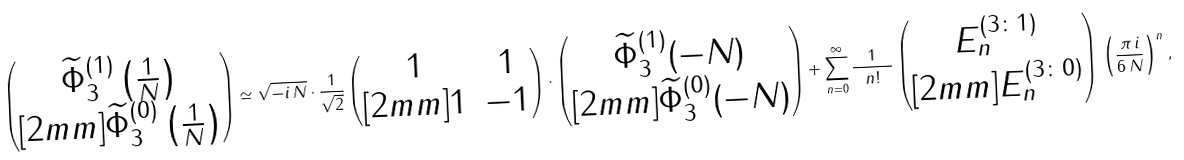<formula> <loc_0><loc_0><loc_500><loc_500>\begin{pmatrix} \widetilde { \Phi } _ { 3 } ^ { ( 1 ) } \left ( \frac { 1 } { N } \right ) \\ [ 2 m m ] \widetilde { \Phi } _ { 3 } ^ { ( 0 ) } \left ( \frac { 1 } { N } \right ) \end{pmatrix} \simeq \sqrt { - i \, N } \cdot \frac { 1 } { \sqrt { 2 } } \begin{pmatrix} 1 & 1 \\ [ 2 m m ] 1 & - 1 \end{pmatrix} \cdot \begin{pmatrix} \widetilde { \Phi } _ { 3 } ^ { ( 1 ) } ( - N ) \\ [ 2 m m ] \widetilde { \Phi } _ { 3 } ^ { ( 0 ) } ( - N ) \end{pmatrix} + \sum _ { n = 0 } ^ { \infty } \frac { 1 } { \ n ! \ } \begin{pmatrix} E _ { n } ^ { ( 3 \colon 1 ) } \\ [ 2 m m ] E _ { n } ^ { ( 3 \colon 0 ) } \end{pmatrix} \, \left ( \frac { \pi \, i } { 6 \, N } \right ) ^ { n } ,</formula> 